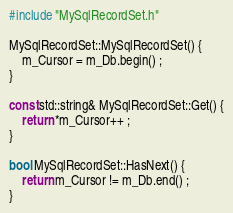<code> <loc_0><loc_0><loc_500><loc_500><_C++_>#include "MySqlRecordSet.h"

MySqlRecordSet::MySqlRecordSet() {
	m_Cursor = m_Db.begin() ;
}

const std::string& MySqlRecordSet::Get() {
	return *m_Cursor++ ;
}

bool MySqlRecordSet::HasNext() {
	return m_Cursor != m_Db.end() ;
}
</code> 